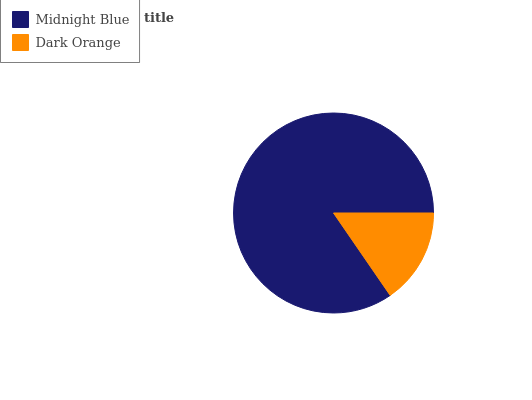Is Dark Orange the minimum?
Answer yes or no. Yes. Is Midnight Blue the maximum?
Answer yes or no. Yes. Is Dark Orange the maximum?
Answer yes or no. No. Is Midnight Blue greater than Dark Orange?
Answer yes or no. Yes. Is Dark Orange less than Midnight Blue?
Answer yes or no. Yes. Is Dark Orange greater than Midnight Blue?
Answer yes or no. No. Is Midnight Blue less than Dark Orange?
Answer yes or no. No. Is Midnight Blue the high median?
Answer yes or no. Yes. Is Dark Orange the low median?
Answer yes or no. Yes. Is Dark Orange the high median?
Answer yes or no. No. Is Midnight Blue the low median?
Answer yes or no. No. 